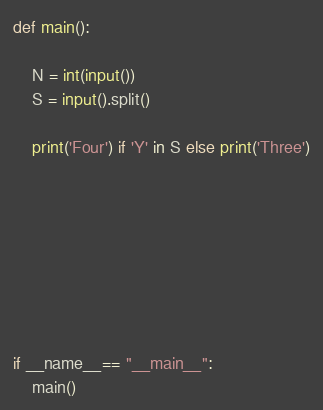<code> <loc_0><loc_0><loc_500><loc_500><_Python_>

def main():

    N = int(input())
    S = input().split()

    print('Four') if 'Y' in S else print('Three')







    
if __name__== "__main__":
    main() 









</code> 